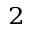<formula> <loc_0><loc_0><loc_500><loc_500>^ { 2 }</formula> 